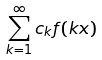<formula> <loc_0><loc_0><loc_500><loc_500>\sum _ { k = 1 } ^ { \infty } c _ { k } f ( k x )</formula> 